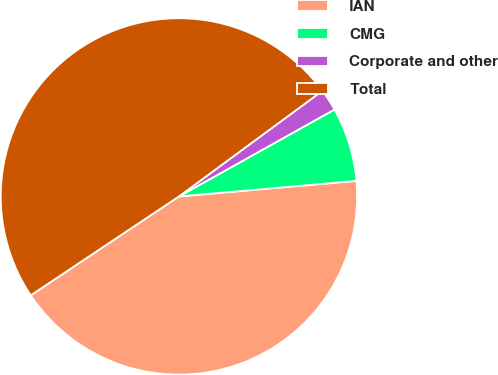Convert chart. <chart><loc_0><loc_0><loc_500><loc_500><pie_chart><fcel>IAN<fcel>CMG<fcel>Corporate and other<fcel>Total<nl><fcel>42.03%<fcel>6.72%<fcel>1.99%<fcel>49.26%<nl></chart> 